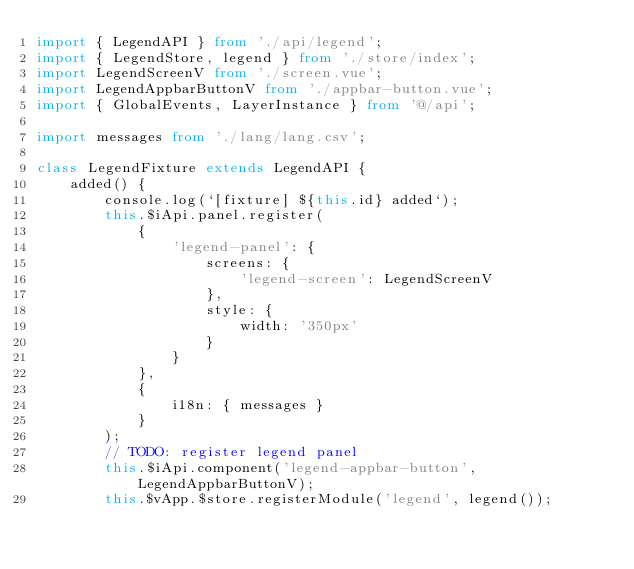<code> <loc_0><loc_0><loc_500><loc_500><_TypeScript_>import { LegendAPI } from './api/legend';
import { LegendStore, legend } from './store/index';
import LegendScreenV from './screen.vue';
import LegendAppbarButtonV from './appbar-button.vue';
import { GlobalEvents, LayerInstance } from '@/api';

import messages from './lang/lang.csv';

class LegendFixture extends LegendAPI {
    added() {
        console.log(`[fixture] ${this.id} added`);
        this.$iApi.panel.register(
            {
                'legend-panel': {
                    screens: {
                        'legend-screen': LegendScreenV
                    },
                    style: {
                        width: '350px'
                    }
                }
            },
            {
                i18n: { messages }
            }
        );
        // TODO: register legend panel
        this.$iApi.component('legend-appbar-button', LegendAppbarButtonV);
        this.$vApp.$store.registerModule('legend', legend());
</code> 